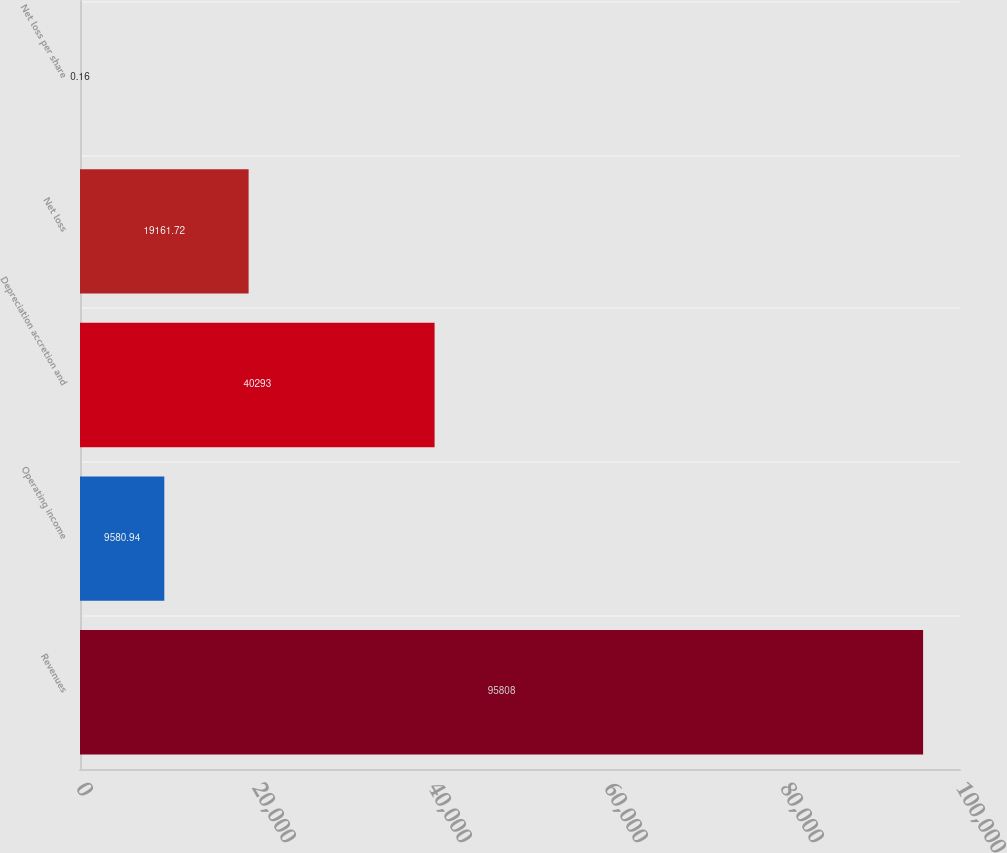<chart> <loc_0><loc_0><loc_500><loc_500><bar_chart><fcel>Revenues<fcel>Operating income<fcel>Depreciation accretion and<fcel>Net loss<fcel>Net loss per share<nl><fcel>95808<fcel>9580.94<fcel>40293<fcel>19161.7<fcel>0.16<nl></chart> 